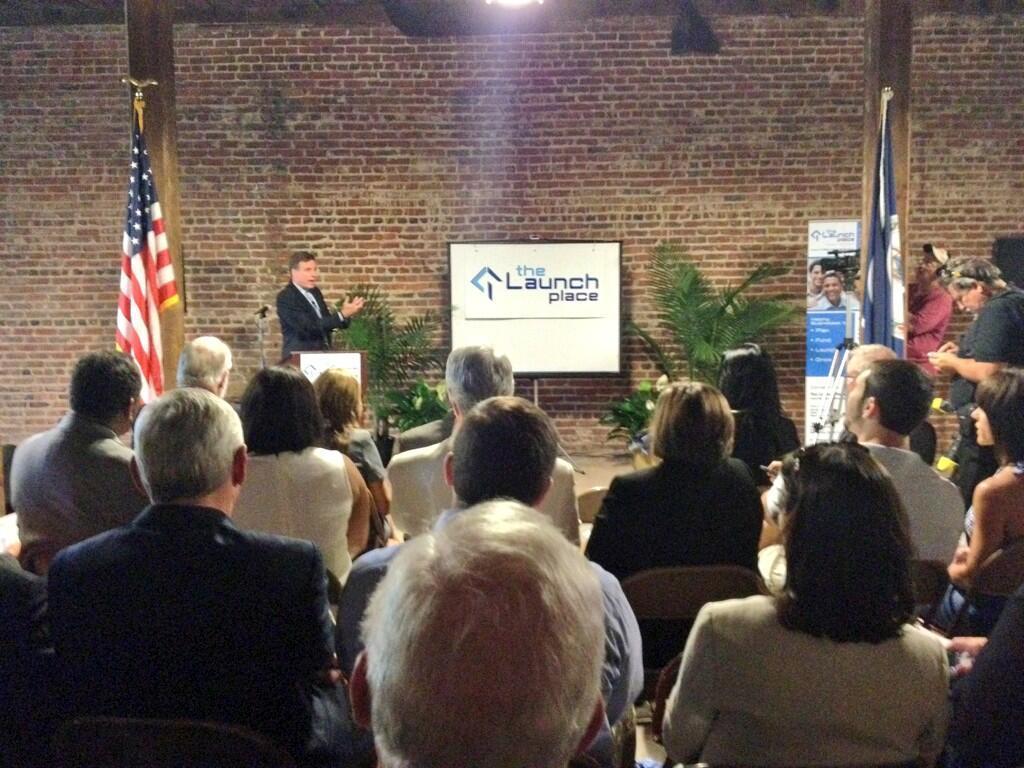Could you give a brief overview of what you see in this image? In the picture we can see some people are sitting and in front of them, we can see a man standing and explaining something, he is in a blazer, tie and shirt and beside him we can see a board with a name on it as the launch place and near it, we can see two plants and behind it we can see the wall and on the top of it we can see a part of the light. 